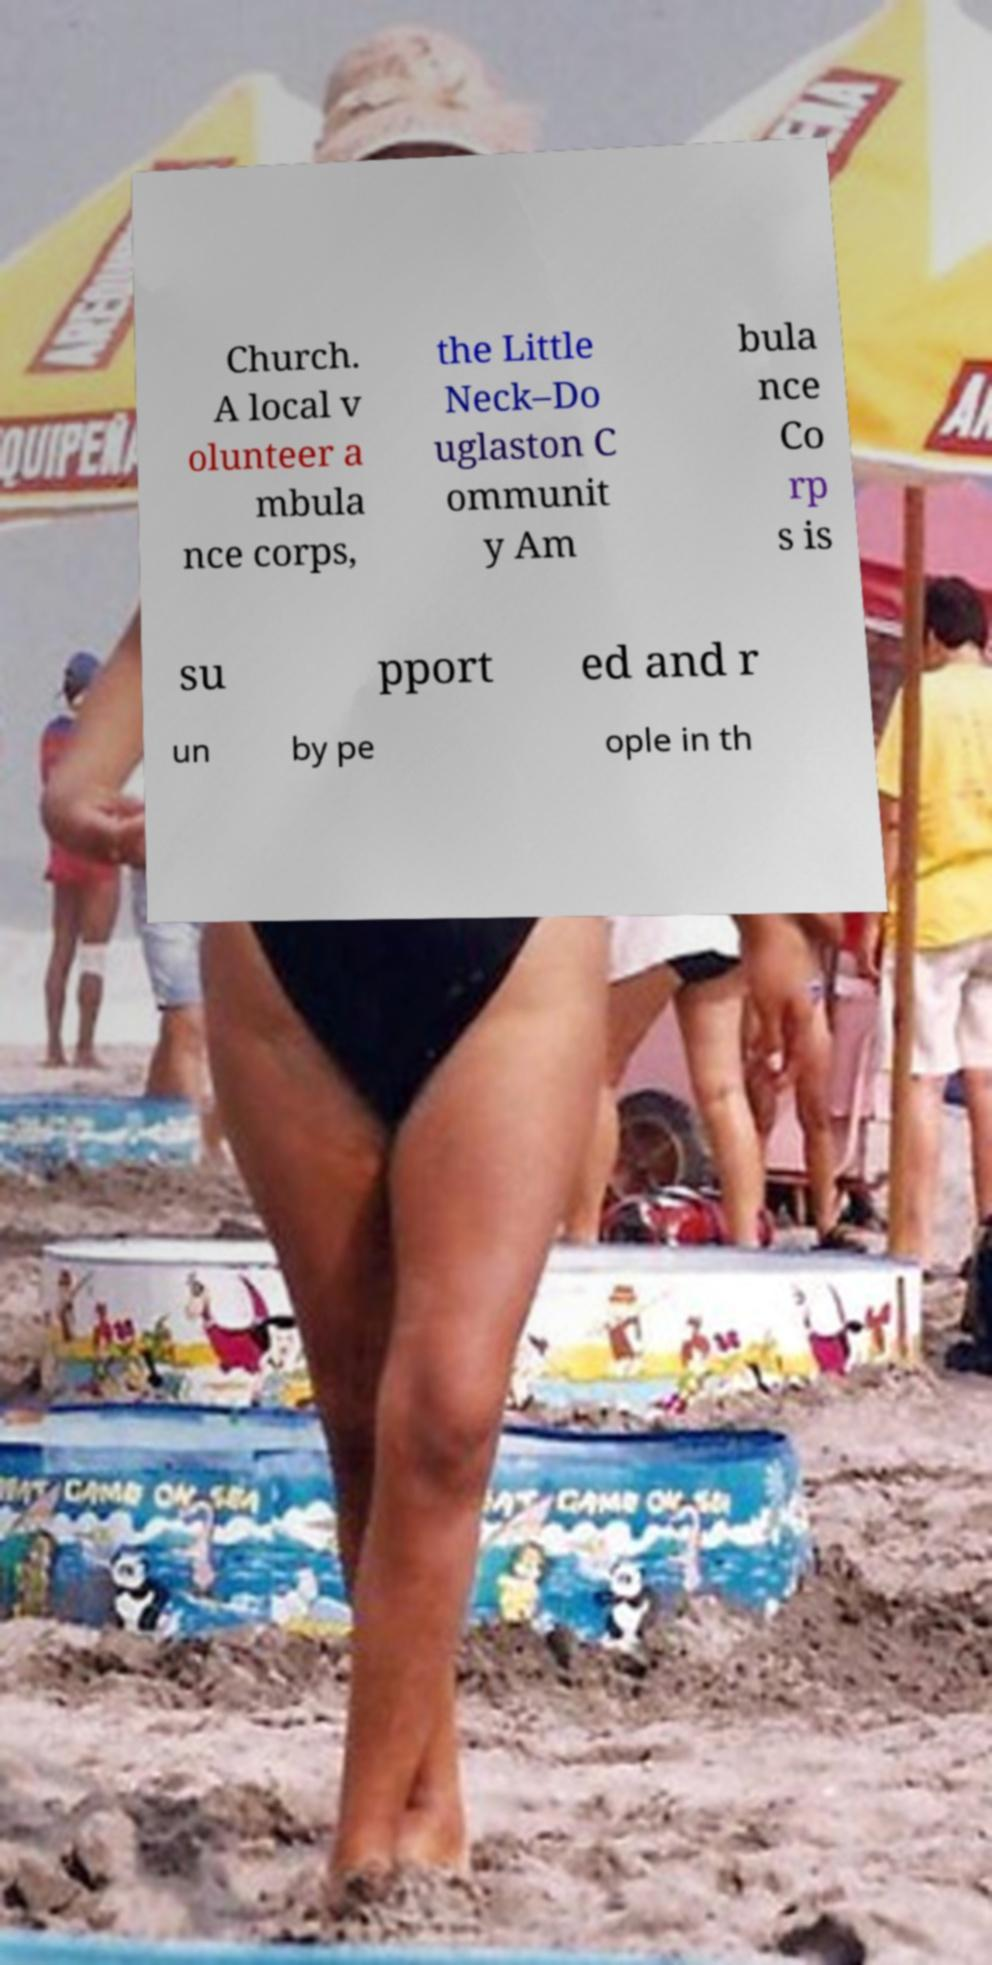What messages or text are displayed in this image? I need them in a readable, typed format. Church. A local v olunteer a mbula nce corps, the Little Neck–Do uglaston C ommunit y Am bula nce Co rp s is su pport ed and r un by pe ople in th 